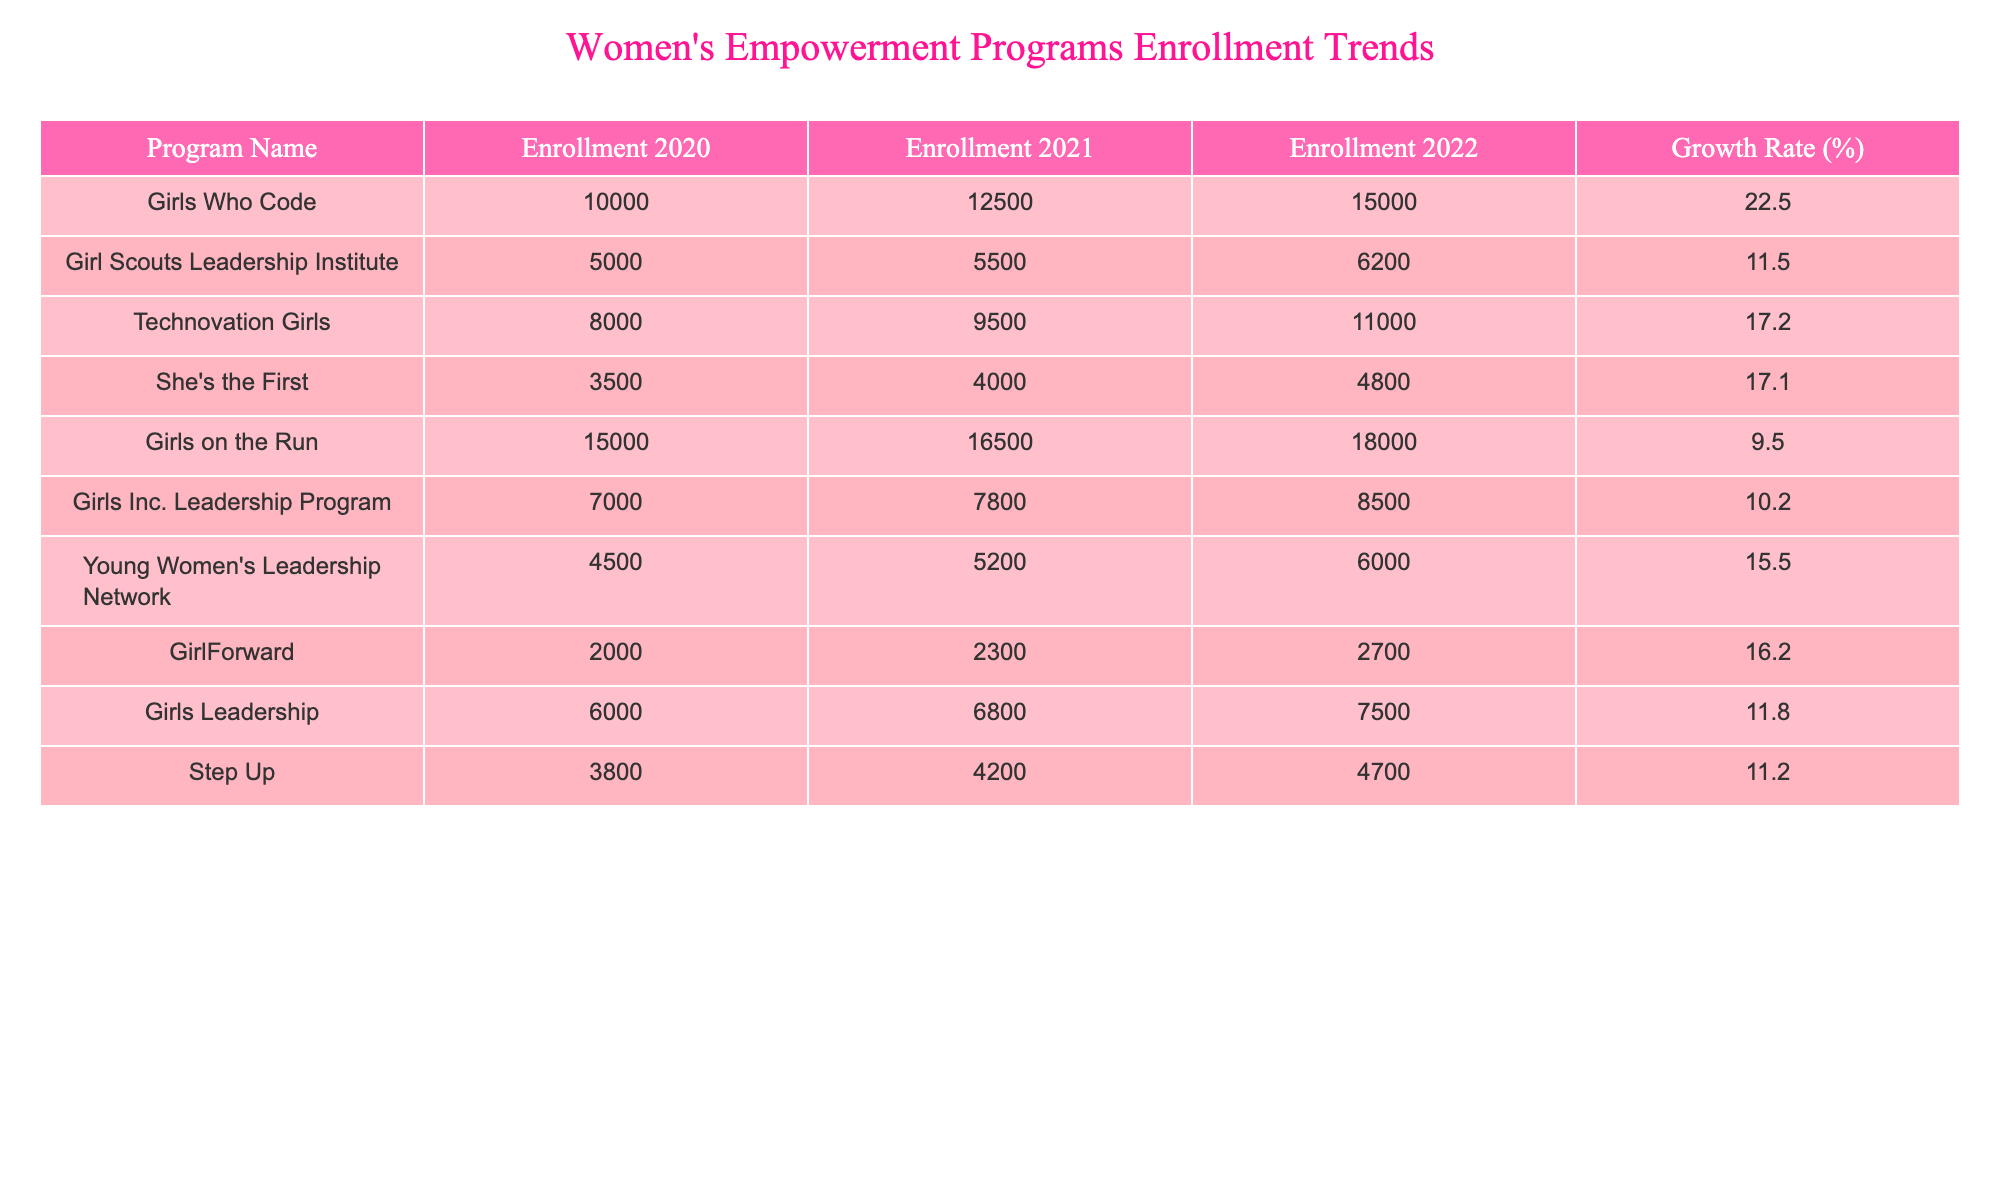What is the enrollment for Girls Who Code in 2022? The table shows the enrollment for Girls Who Code in 2022 listed under the "Enrollment 2022" column. The value is 15,000.
Answer: 15,000 Which program had the highest enrollment in 2021? Looking at the 2021 column, Girls on the Run has the highest enrollment at 16,500, compared to other programs in that year.
Answer: Girls on the Run What was the growth rate for She's the First? The table states the growth rate for She's the First under "Growth Rate (%)" as 17.1%.
Answer: 17.1% How much did enrollment increase for Girl Scouts Leadership Institute from 2020 to 2022? To find this, subtract the 2020 enrollment (5,000) from the 2022 enrollment (6,200), which gives us 6,200 - 5,000 = 1,200.
Answer: 1,200 What is the average enrollment across all programs in 2022? First, sum all the enrollments for 2022: 15,000 + 6,200 + 11,000 + 4,800 + 18,000 + 8,500 + 6,000 + 2,700 + 7,500 + 4,700 = 79,400. There are 10 programs, so the average is 79,400 / 10 = 7,940.
Answer: 7,940 Did any program have a growth rate of over 20%? By checking the growth rates listed in the table, Girls Who Code has a growth rate of 22.5%, which is over 20%.
Answer: Yes What was the total enrollment growth for Girls on the Run from 2020 to 2022? The enrollment in 2020 was 15,000 and in 2022 it was 18,000. The difference is 18,000 - 15,000 = 3,000.
Answer: 3,000 Which program had the lowest enrollment in 2020? Looking at the enrollment in 2020, GirlForward has the lowest enrollment at 2,000.
Answer: GirlForward How does the enrollment of Technovation Girls in 2021 compare to that of Girls Leadership? Technovation Girls had an enrollment of 9,500 in 2021, while Girls Leadership had 6,800. Since 9,500 is greater than 6,800, Technovation Girls had higher enrollment.
Answer: Higher List the program names that had an enrollment of 5,000 or more in 2022. In the 2022 enrollment, the following programs had 5,000 or more: Girls Who Code, Girls on the Run, Technovation Girls, Girl Scouts Leadership Institute, Girls Inc. Leadership Program, Young Women's Leadership Network.
Answer: 6 programs Is there a program that had a consistent growth rate over the three years? By examining growth rates for each program over the three years, none are listed with exactly the same growth rate for all years; therefore, there is no consistent growth rate program.
Answer: No 